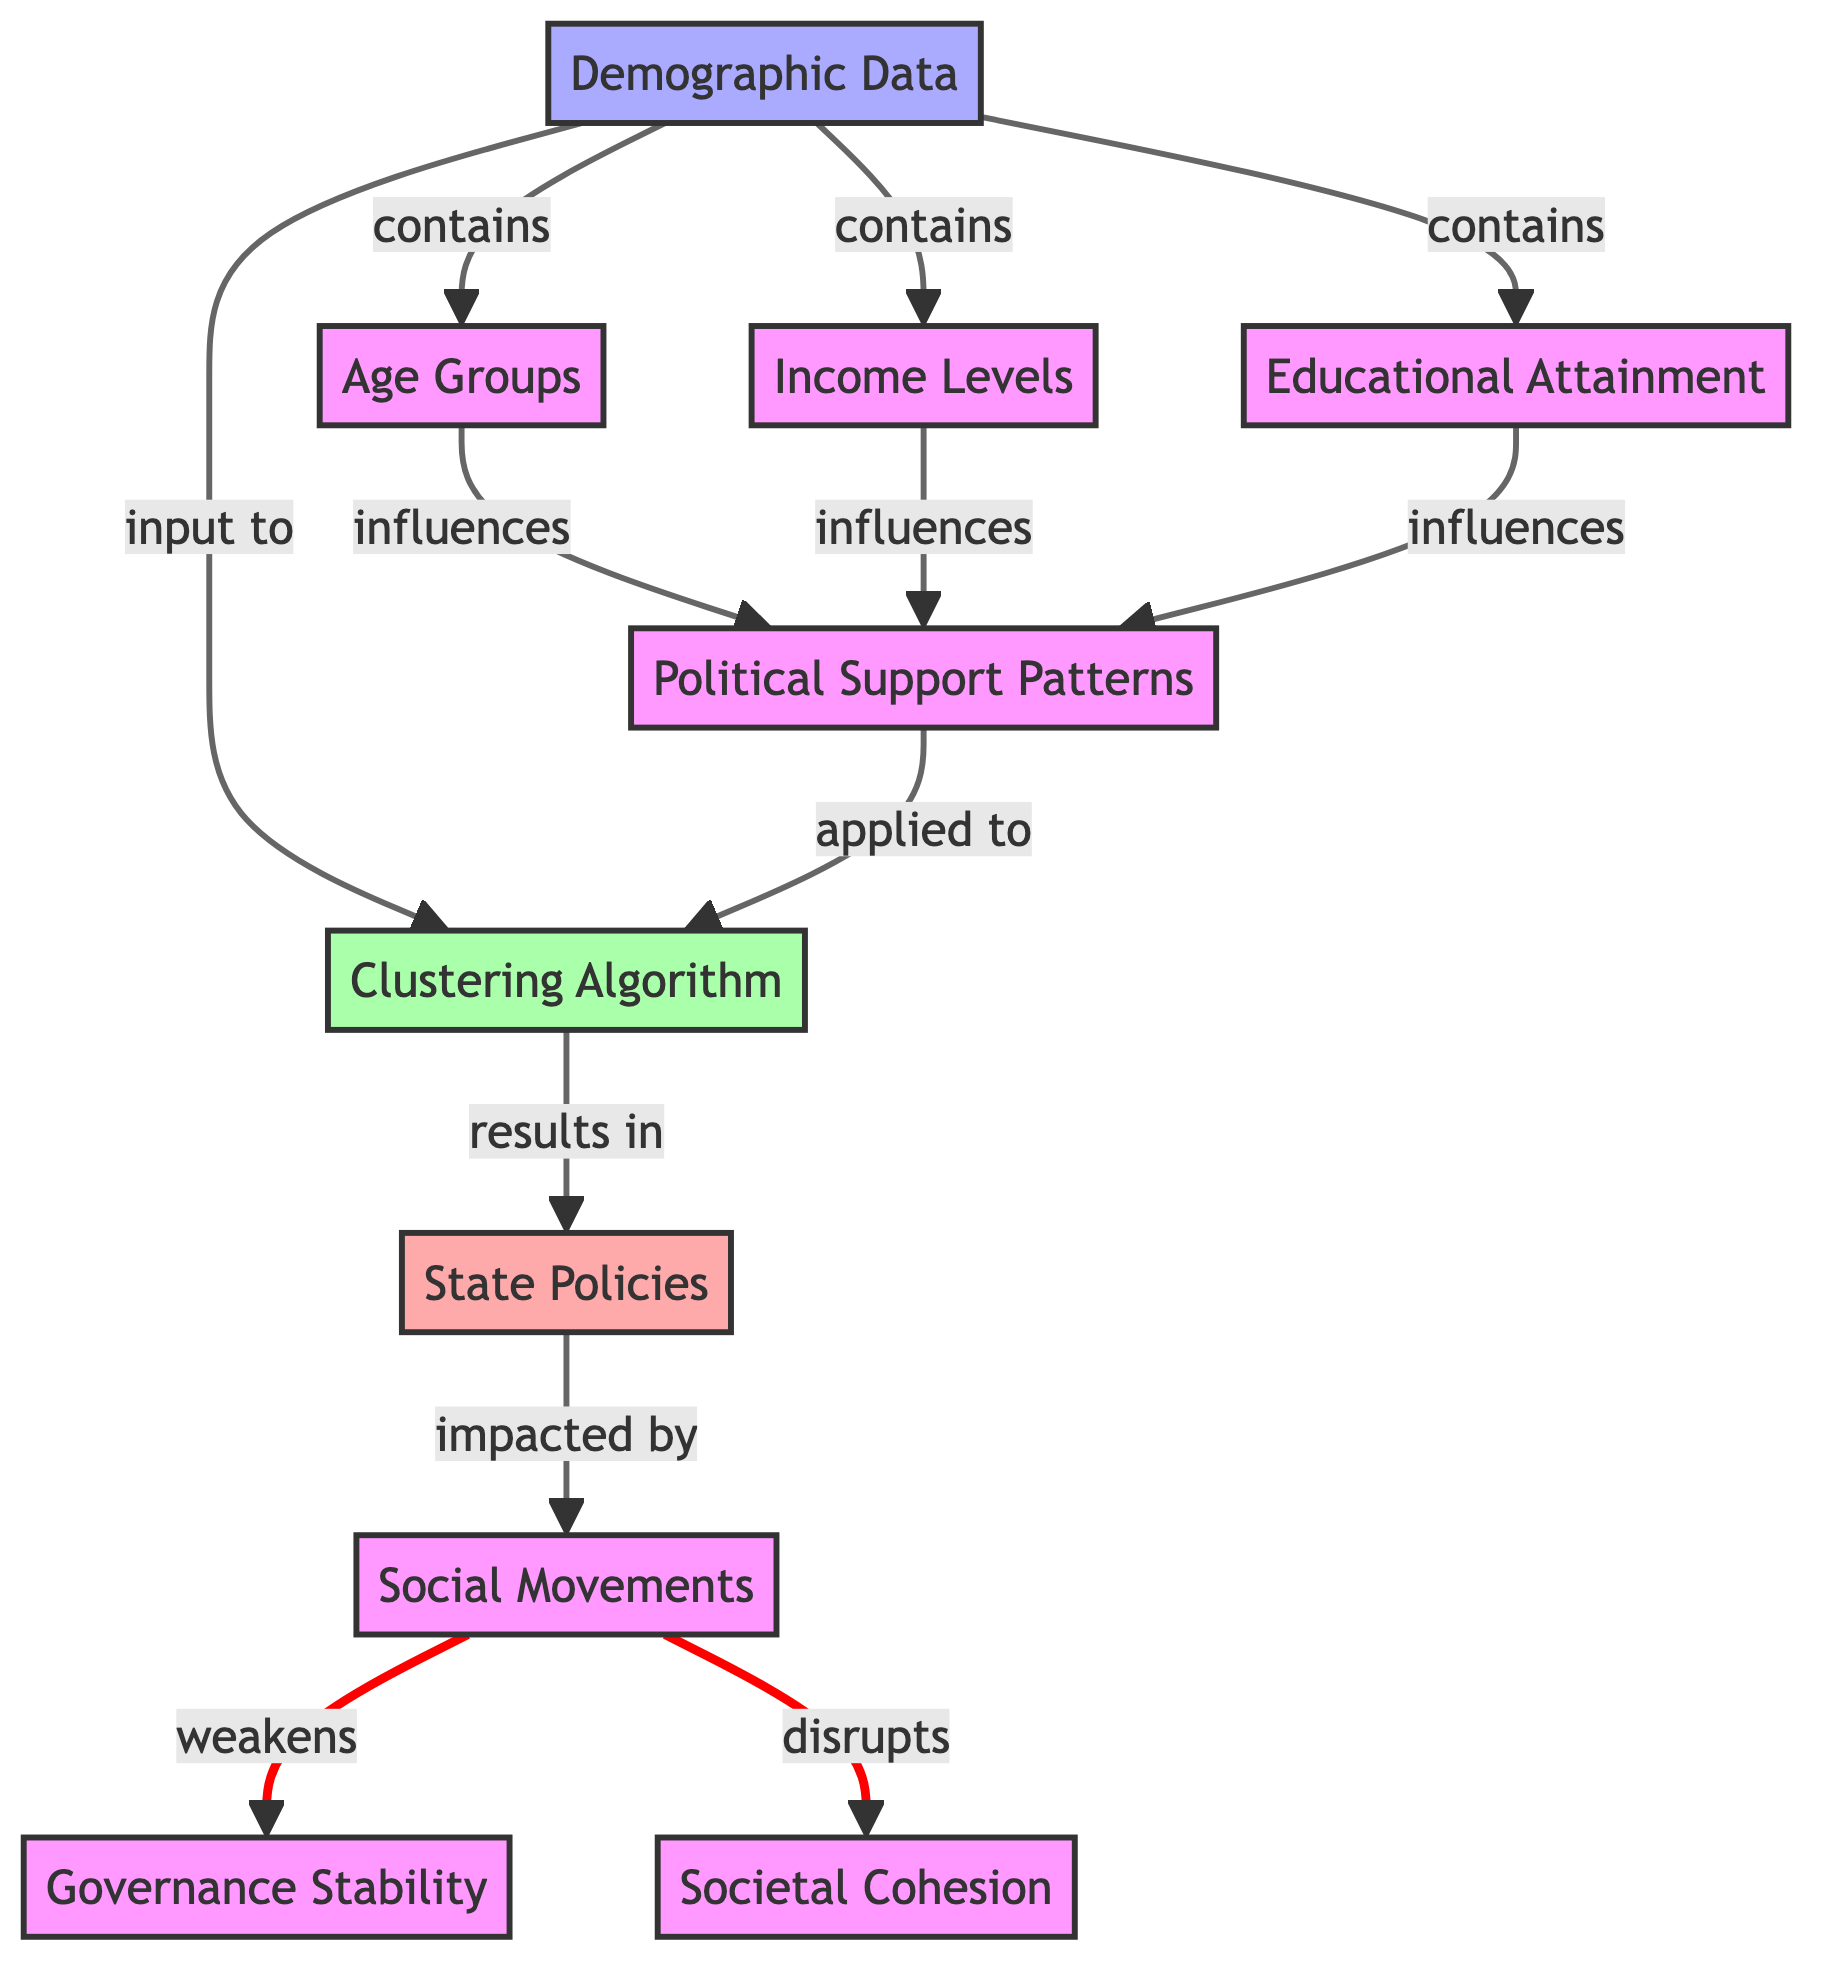What is the primary input to the clustering algorithm? The clustering algorithm takes demographic data as its primary input, as indicated by the directed edge leading to the algorithm.
Answer: Demographic Data How many demographic factors influence political support patterns? The diagram shows three specific demographic factors: Age Groups, Income Levels, and Educational Attainment, which together influence political support patterns.
Answer: Three Which elements in the diagram are directly affected by social movements? The diagram indicates that social movements weaken governance stability and disrupt societal cohesion, showing the direct impact on these two elements.
Answer: Governance Stability, Societal Cohesion What type of relationship exists between demographic data and the clustering algorithm? The relationship is identified as an input relationship, showing that demographic data is necessary for the clustering algorithm to operate correctly, as indicated by the directed edge.
Answer: Input How does educational attainment influence political support patterns? Educational attainment influences political support patterns as one of the demographic components, as depicted in the diagram where it is linked directly to political support patterns.
Answer: Influences What is the result of applying the clustering algorithm? The output of the clustering algorithm is the state policies, as evidenced by the directed edge leading from the clustering algorithm to the output node representing state policies.
Answer: State Policies What type of algorithm is represented in this diagram? The diagram features a clustering algorithm specifically, which is a type of machine learning algorithm used for grouping data based on similarities.
Answer: Clustering Algorithm Which social movement impacts governance stability and societal cohesion in the diagram? The diagram indicates that social movements are a disruptive force that weakens governance stability and disrupts societal cohesion through their overall influence.
Answer: Social Movements What nodes are related to income levels in the diagram? Income levels directly influence political support patterns as shown by the directed edge leading to the respective node, highlighting its relevance in the context of the diagram.
Answer: Political Support Patterns 